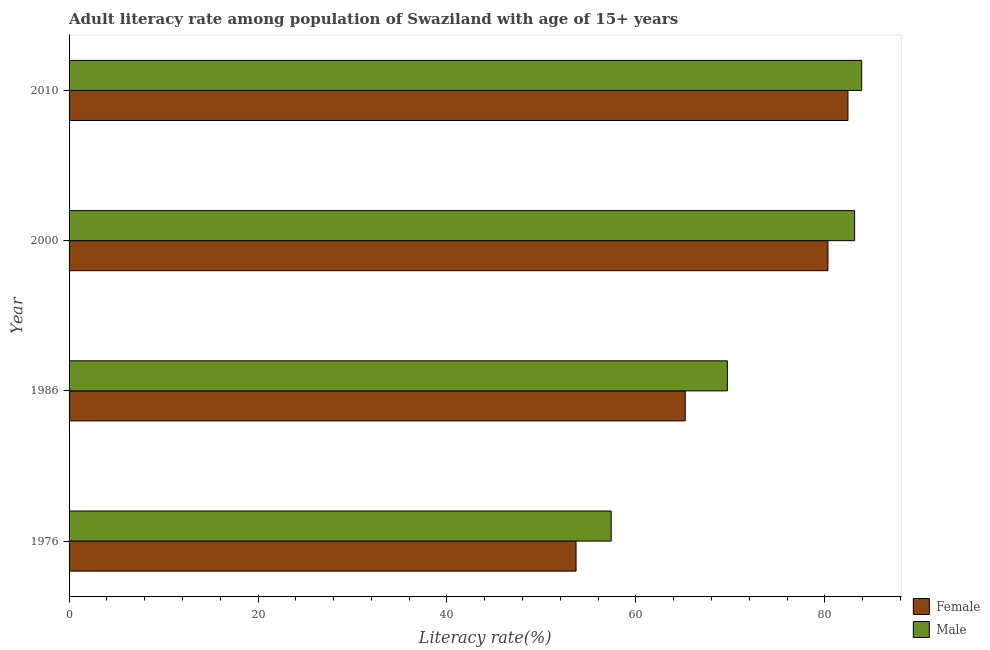Are the number of bars per tick equal to the number of legend labels?
Provide a succinct answer. Yes. Are the number of bars on each tick of the Y-axis equal?
Make the answer very short. Yes. How many bars are there on the 2nd tick from the bottom?
Give a very brief answer. 2. What is the label of the 4th group of bars from the top?
Your answer should be very brief. 1976. In how many cases, is the number of bars for a given year not equal to the number of legend labels?
Your answer should be compact. 0. What is the male adult literacy rate in 1986?
Ensure brevity in your answer.  69.68. Across all years, what is the maximum female adult literacy rate?
Provide a succinct answer. 82.45. Across all years, what is the minimum male adult literacy rate?
Your response must be concise. 57.38. In which year was the female adult literacy rate minimum?
Ensure brevity in your answer.  1976. What is the total male adult literacy rate in the graph?
Ensure brevity in your answer.  294.12. What is the difference between the male adult literacy rate in 1986 and that in 2010?
Provide a succinct answer. -14.22. What is the difference between the male adult literacy rate in 2010 and the female adult literacy rate in 1976?
Provide a short and direct response. 30.23. What is the average male adult literacy rate per year?
Provide a short and direct response. 73.53. In the year 2010, what is the difference between the male adult literacy rate and female adult literacy rate?
Your answer should be compact. 1.45. In how many years, is the male adult literacy rate greater than 4 %?
Make the answer very short. 4. What is the difference between the highest and the second highest female adult literacy rate?
Ensure brevity in your answer.  2.12. What is the difference between the highest and the lowest female adult literacy rate?
Make the answer very short. 28.78. In how many years, is the female adult literacy rate greater than the average female adult literacy rate taken over all years?
Provide a succinct answer. 2. Is the sum of the female adult literacy rate in 1986 and 2010 greater than the maximum male adult literacy rate across all years?
Your response must be concise. Yes. How many years are there in the graph?
Give a very brief answer. 4. What is the difference between two consecutive major ticks on the X-axis?
Your response must be concise. 20. Where does the legend appear in the graph?
Provide a short and direct response. Bottom right. How many legend labels are there?
Ensure brevity in your answer.  2. What is the title of the graph?
Provide a succinct answer. Adult literacy rate among population of Swaziland with age of 15+ years. Does "Highest 10% of population" appear as one of the legend labels in the graph?
Offer a very short reply. No. What is the label or title of the X-axis?
Make the answer very short. Literacy rate(%). What is the label or title of the Y-axis?
Your answer should be very brief. Year. What is the Literacy rate(%) of Female in 1976?
Your answer should be compact. 53.67. What is the Literacy rate(%) of Male in 1976?
Ensure brevity in your answer.  57.38. What is the Literacy rate(%) of Female in 1986?
Provide a succinct answer. 65.22. What is the Literacy rate(%) of Male in 1986?
Offer a very short reply. 69.68. What is the Literacy rate(%) of Female in 2000?
Offer a terse response. 80.33. What is the Literacy rate(%) of Male in 2000?
Your response must be concise. 83.15. What is the Literacy rate(%) in Female in 2010?
Ensure brevity in your answer.  82.45. What is the Literacy rate(%) of Male in 2010?
Provide a succinct answer. 83.9. Across all years, what is the maximum Literacy rate(%) of Female?
Make the answer very short. 82.45. Across all years, what is the maximum Literacy rate(%) of Male?
Offer a very short reply. 83.9. Across all years, what is the minimum Literacy rate(%) of Female?
Make the answer very short. 53.67. Across all years, what is the minimum Literacy rate(%) of Male?
Make the answer very short. 57.38. What is the total Literacy rate(%) of Female in the graph?
Provide a short and direct response. 281.67. What is the total Literacy rate(%) in Male in the graph?
Keep it short and to the point. 294.12. What is the difference between the Literacy rate(%) in Female in 1976 and that in 1986?
Make the answer very short. -11.56. What is the difference between the Literacy rate(%) in Male in 1976 and that in 1986?
Provide a short and direct response. -12.3. What is the difference between the Literacy rate(%) of Female in 1976 and that in 2000?
Ensure brevity in your answer.  -26.66. What is the difference between the Literacy rate(%) of Male in 1976 and that in 2000?
Give a very brief answer. -25.77. What is the difference between the Literacy rate(%) in Female in 1976 and that in 2010?
Offer a terse response. -28.78. What is the difference between the Literacy rate(%) in Male in 1976 and that in 2010?
Offer a terse response. -26.52. What is the difference between the Literacy rate(%) in Female in 1986 and that in 2000?
Keep it short and to the point. -15.11. What is the difference between the Literacy rate(%) of Male in 1986 and that in 2000?
Offer a terse response. -13.47. What is the difference between the Literacy rate(%) in Female in 1986 and that in 2010?
Offer a very short reply. -17.22. What is the difference between the Literacy rate(%) in Male in 1986 and that in 2010?
Give a very brief answer. -14.22. What is the difference between the Literacy rate(%) of Female in 2000 and that in 2010?
Provide a short and direct response. -2.12. What is the difference between the Literacy rate(%) of Male in 2000 and that in 2010?
Offer a terse response. -0.75. What is the difference between the Literacy rate(%) of Female in 1976 and the Literacy rate(%) of Male in 1986?
Your response must be concise. -16.02. What is the difference between the Literacy rate(%) of Female in 1976 and the Literacy rate(%) of Male in 2000?
Provide a short and direct response. -29.49. What is the difference between the Literacy rate(%) in Female in 1976 and the Literacy rate(%) in Male in 2010?
Provide a short and direct response. -30.23. What is the difference between the Literacy rate(%) of Female in 1986 and the Literacy rate(%) of Male in 2000?
Provide a short and direct response. -17.93. What is the difference between the Literacy rate(%) in Female in 1986 and the Literacy rate(%) in Male in 2010?
Offer a terse response. -18.68. What is the difference between the Literacy rate(%) in Female in 2000 and the Literacy rate(%) in Male in 2010?
Your answer should be compact. -3.57. What is the average Literacy rate(%) of Female per year?
Keep it short and to the point. 70.42. What is the average Literacy rate(%) in Male per year?
Ensure brevity in your answer.  73.53. In the year 1976, what is the difference between the Literacy rate(%) of Female and Literacy rate(%) of Male?
Your answer should be compact. -3.72. In the year 1986, what is the difference between the Literacy rate(%) in Female and Literacy rate(%) in Male?
Provide a succinct answer. -4.46. In the year 2000, what is the difference between the Literacy rate(%) in Female and Literacy rate(%) in Male?
Give a very brief answer. -2.83. In the year 2010, what is the difference between the Literacy rate(%) in Female and Literacy rate(%) in Male?
Keep it short and to the point. -1.45. What is the ratio of the Literacy rate(%) in Female in 1976 to that in 1986?
Offer a very short reply. 0.82. What is the ratio of the Literacy rate(%) of Male in 1976 to that in 1986?
Offer a very short reply. 0.82. What is the ratio of the Literacy rate(%) of Female in 1976 to that in 2000?
Your answer should be compact. 0.67. What is the ratio of the Literacy rate(%) in Male in 1976 to that in 2000?
Your answer should be very brief. 0.69. What is the ratio of the Literacy rate(%) in Female in 1976 to that in 2010?
Make the answer very short. 0.65. What is the ratio of the Literacy rate(%) of Male in 1976 to that in 2010?
Give a very brief answer. 0.68. What is the ratio of the Literacy rate(%) in Female in 1986 to that in 2000?
Your answer should be very brief. 0.81. What is the ratio of the Literacy rate(%) of Male in 1986 to that in 2000?
Offer a very short reply. 0.84. What is the ratio of the Literacy rate(%) in Female in 1986 to that in 2010?
Your answer should be compact. 0.79. What is the ratio of the Literacy rate(%) of Male in 1986 to that in 2010?
Make the answer very short. 0.83. What is the ratio of the Literacy rate(%) of Female in 2000 to that in 2010?
Give a very brief answer. 0.97. What is the ratio of the Literacy rate(%) of Male in 2000 to that in 2010?
Make the answer very short. 0.99. What is the difference between the highest and the second highest Literacy rate(%) in Female?
Give a very brief answer. 2.12. What is the difference between the highest and the second highest Literacy rate(%) in Male?
Your answer should be compact. 0.75. What is the difference between the highest and the lowest Literacy rate(%) of Female?
Provide a short and direct response. 28.78. What is the difference between the highest and the lowest Literacy rate(%) in Male?
Your answer should be compact. 26.52. 